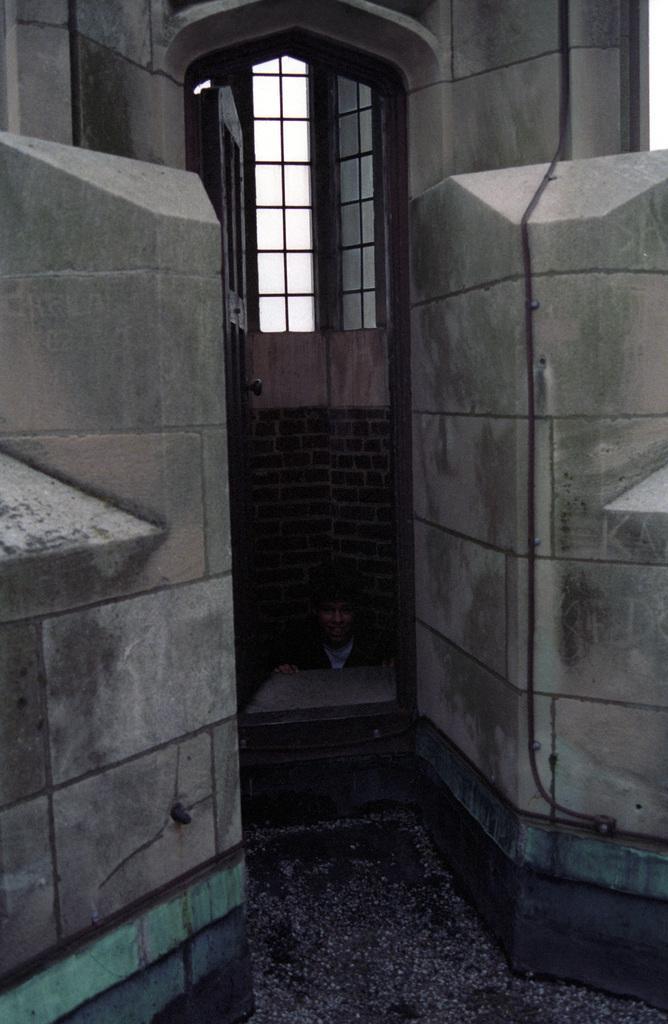Could you give a brief overview of what you see in this image? This picture shows a building and a door of it and in the door we can see a person sitting down 